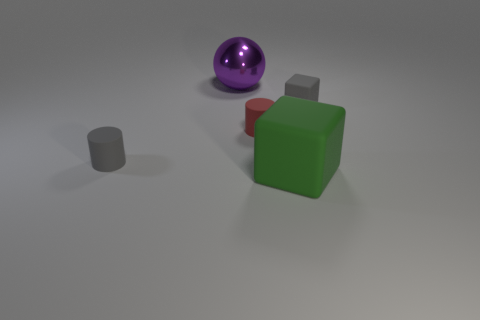Is the number of purple metallic things greater than the number of blue blocks?
Ensure brevity in your answer.  Yes. Do the tiny red thing and the big green rubber thing have the same shape?
Provide a succinct answer. No. Are there any other things that are the same shape as the metal thing?
Offer a very short reply. No. Does the block on the right side of the green matte object have the same color as the small matte cylinder to the right of the gray cylinder?
Give a very brief answer. No. Is the number of tiny red matte objects that are behind the gray rubber block less than the number of large purple shiny things that are in front of the big green matte object?
Provide a succinct answer. No. There is a small thing that is to the left of the large purple shiny sphere; what is its shape?
Keep it short and to the point. Cylinder. What material is the object that is the same color as the tiny matte cube?
Ensure brevity in your answer.  Rubber. What number of other things are there of the same material as the red thing
Ensure brevity in your answer.  3. There is a large green matte thing; does it have the same shape as the small matte thing to the right of the big block?
Give a very brief answer. Yes. There is a large thing that is the same material as the tiny gray block; what shape is it?
Your response must be concise. Cube. 